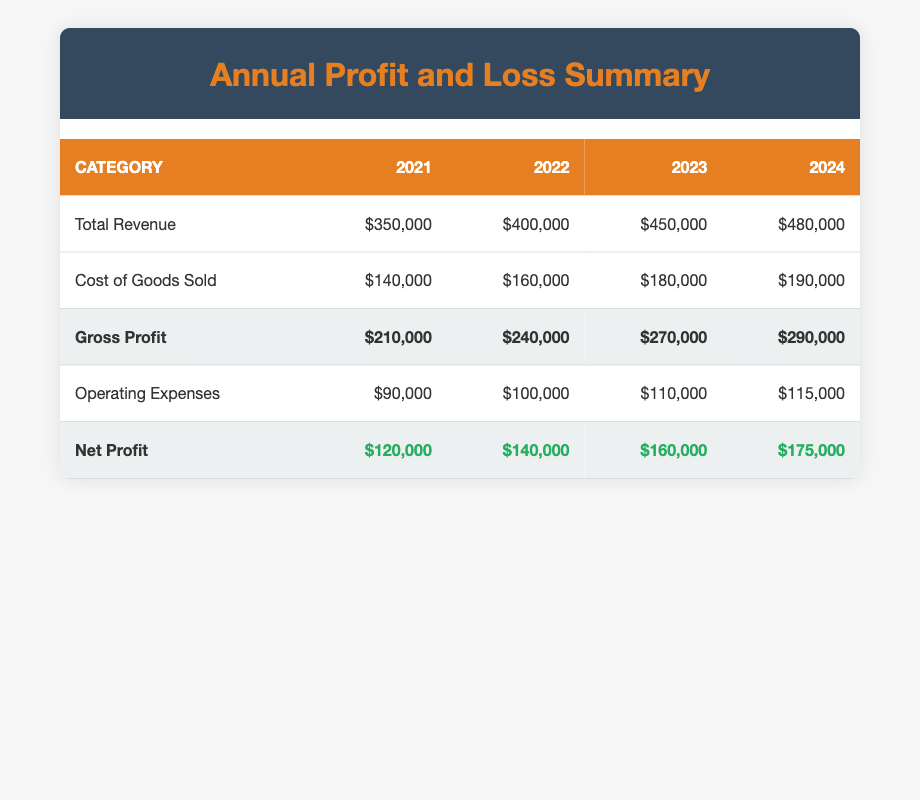What was the total revenue in 2023? The table shows that the total revenue in the year 2023 is listed under the "Total Revenue" row and the "2023" column, which is $450,000.
Answer: $450,000 What is the net profit for 2024? According to the table, the net profit for the year 2024 is indicated in the "Net Profit" row and the "2024" column, which is $175,000.
Answer: $175,000 Is the gross profit for 2022 greater than the cost of goods sold for 2021? To verify this, we check the gross profit for 2022 from the "Gross Profit" row (which is $240,000) and the cost of goods sold for 2021 from the "Cost of Goods Sold" row (which is $140,000). Since $240,000 is greater than $140,000, the answer is yes.
Answer: Yes What was the increase in net profit from 2022 to 2023? We find the net profit for 2022 ($140,000) and for 2023 ($160,000). The increase is calculated by subtracting the two values: $160,000 - $140,000 = $20,000.
Answer: $20,000 Was the total revenue in 2024 less than in 2023? We need to compare the total revenues for both years. The total revenue for 2023 is $450,000, and for 2024 it is $480,000. Since $480,000 is greater than $450,000, the answer is no.
Answer: No What is the average gross profit from 2021 to 2024? To find the average gross profit, we need to sum the gross profits for each year: $210,000 + $240,000 + $270,000 + $290,000 = $1,010,000. Then, we divide this total by the number of years (4): $1,010,000 / 4 = $252,500.
Answer: $252,500 In which year did the operating expenses reach $100,000 or more? Checking the operating expenses for each year, we find that they are $90,000 in 2021, $100,000 in 2022, $110,000 in 2023, and $115,000 in 2024. Therefore, operating expenses were at least $100,000 starting in 2022.
Answer: 2022 What was the total increase in gross profit from 2021 to 2024? We first find the gross profits for the two years: for 2021 it is $210,000 and for 2024 it is $290,000. Next, we calculate the increase by subtracting: $290,000 - $210,000 = $80,000.
Answer: $80,000 